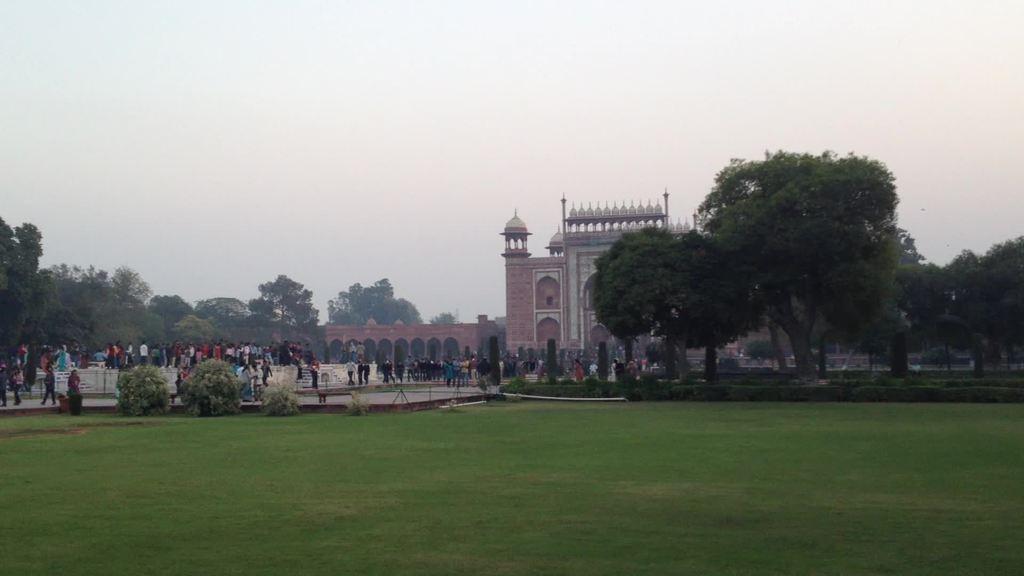Could you give a brief overview of what you see in this image? In this image we can see grass on the ground. There are bushes. Also there are many people. And there are many trees. And there is a monument. In the background there is sky. 